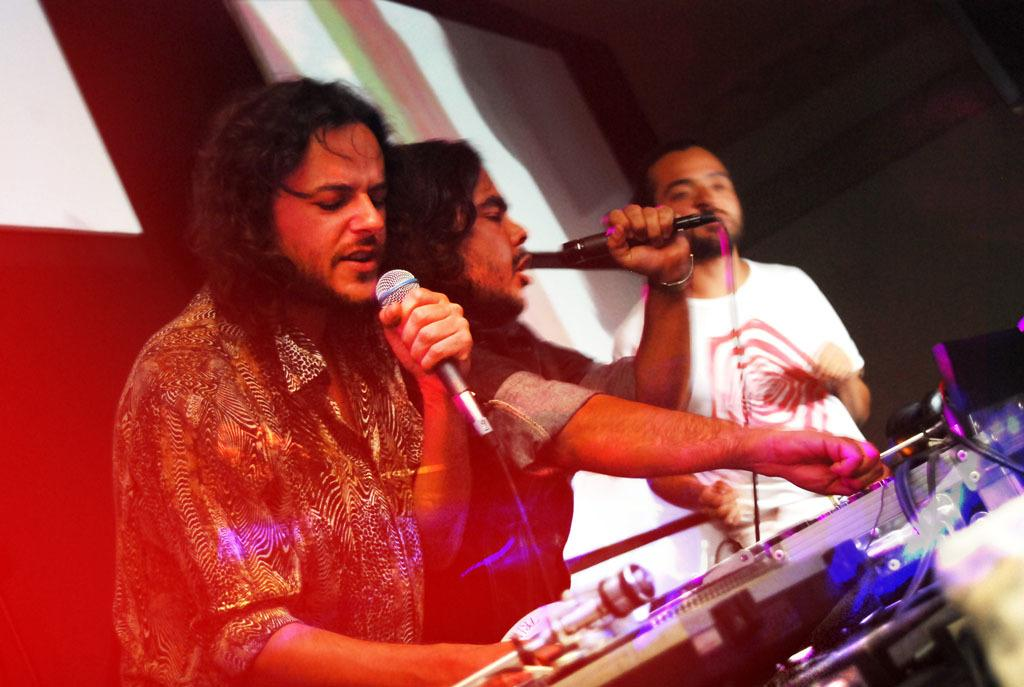How many people are in the image? There are three men in the image. What are two of the men doing in the image? Two of the men are holding microphones. What can be seen on the right side of the image? There is audio visual equipment on the right side of the image. What is the history of the park where the men are standing in the image? There is no park present in the image, so it is not possible to discuss the history of a park in this context. 